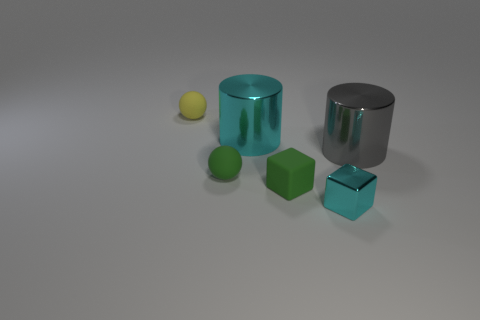Add 3 small yellow balls. How many objects exist? 9 Subtract all spheres. How many objects are left? 4 Add 6 tiny green rubber cubes. How many tiny green rubber cubes exist? 7 Subtract 1 green blocks. How many objects are left? 5 Subtract all small gray objects. Subtract all cyan objects. How many objects are left? 4 Add 4 cyan metallic blocks. How many cyan metallic blocks are left? 5 